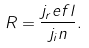<formula> <loc_0><loc_0><loc_500><loc_500>R = \frac { j _ { r } e f l } { j _ { i } n } .</formula> 